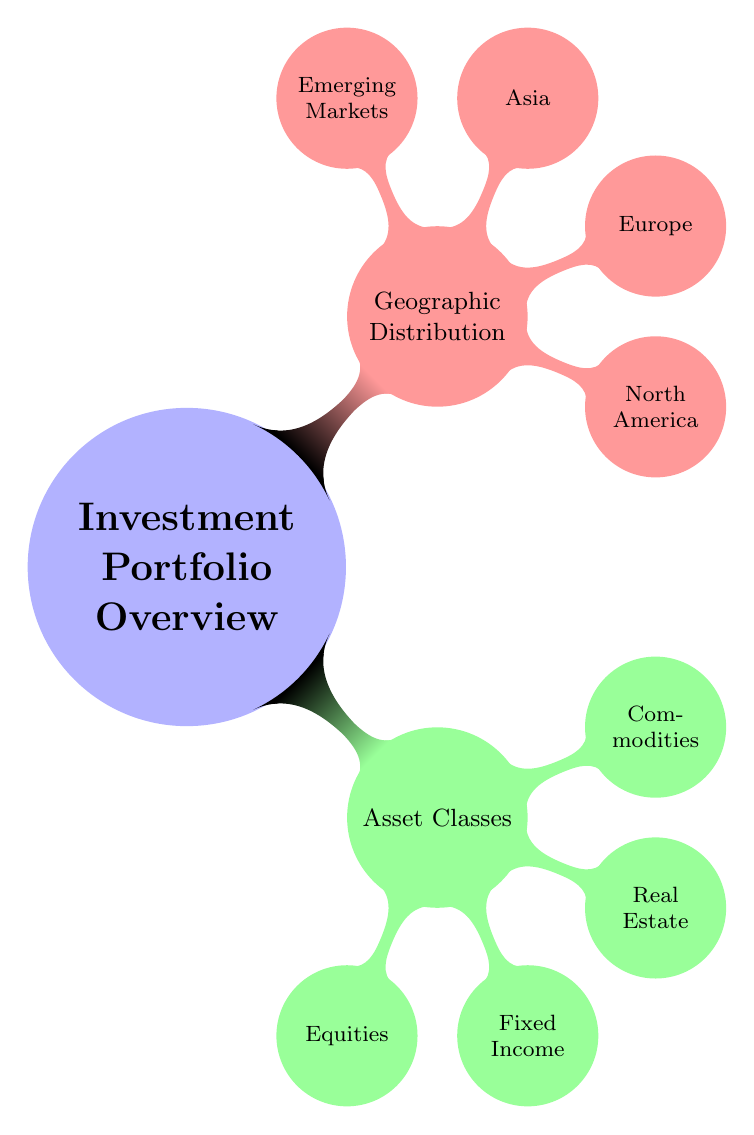What are the asset classes in the investment portfolio? The diagram lists four asset classes under the "Asset Classes" node: Equities, Fixed Income, Real Estate, and Commodities.
Answer: Equities, Fixed Income, Real Estate, Commodities How many geographic regions are represented in the diagram? The "Geographic Distribution" node contains four regions: North America, Europe, Asia, and Emerging Markets, indicating a total of four regions.
Answer: 4 Which asset class includes corporate bonds? By examining the "Asset Classes" node, corporate bonds are specifically listed under the "Fixed Income" sub-node.
Answer: Fixed Income What is the example of an equity in emerging markets? The diagram shows that Tencent Holdings and Reliance Industries are categorized as equities in the "Emerging Markets" section under "Equities."
Answer: Tencent Holdings, Reliance Industries Which geographic region contains the Shanghai Composite Index Fund? The "Asia" node includes the "China" sub-node, which specifically lists the Shanghai Composite Index Fund.
Answer: Asia (China) How many types of real estate are listed in the mind map? Under the "Real Estate" node, there are two types mentioned: Commercial and Residential, indicating there are two types.
Answer: 2 Which asset class is associated with gold? Gold is categorized under the "Commodities" node specifically listed as a type of Precious Metal, indicating its classification.
Answer: Commodities What is the index fund listed under Canada in the geographic distribution? The "Canada" section of the "North America" node refers to the "TSX Composite Index," which directly answers the query about the index fund.
Answer: TSX Composite Index What is the relationship between North America and Asset Classes? The "North America" region and "Asset Classes" are distinct categories; however, investment portfolios can combine these through specific assets like the S&P 500 Index Fund found in North America.
Answer: Combination of regions and classes 